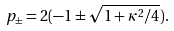Convert formula to latex. <formula><loc_0><loc_0><loc_500><loc_500>p _ { \pm } = 2 ( - 1 \pm \sqrt { 1 + \kappa ^ { 2 } / 4 } ) .</formula> 